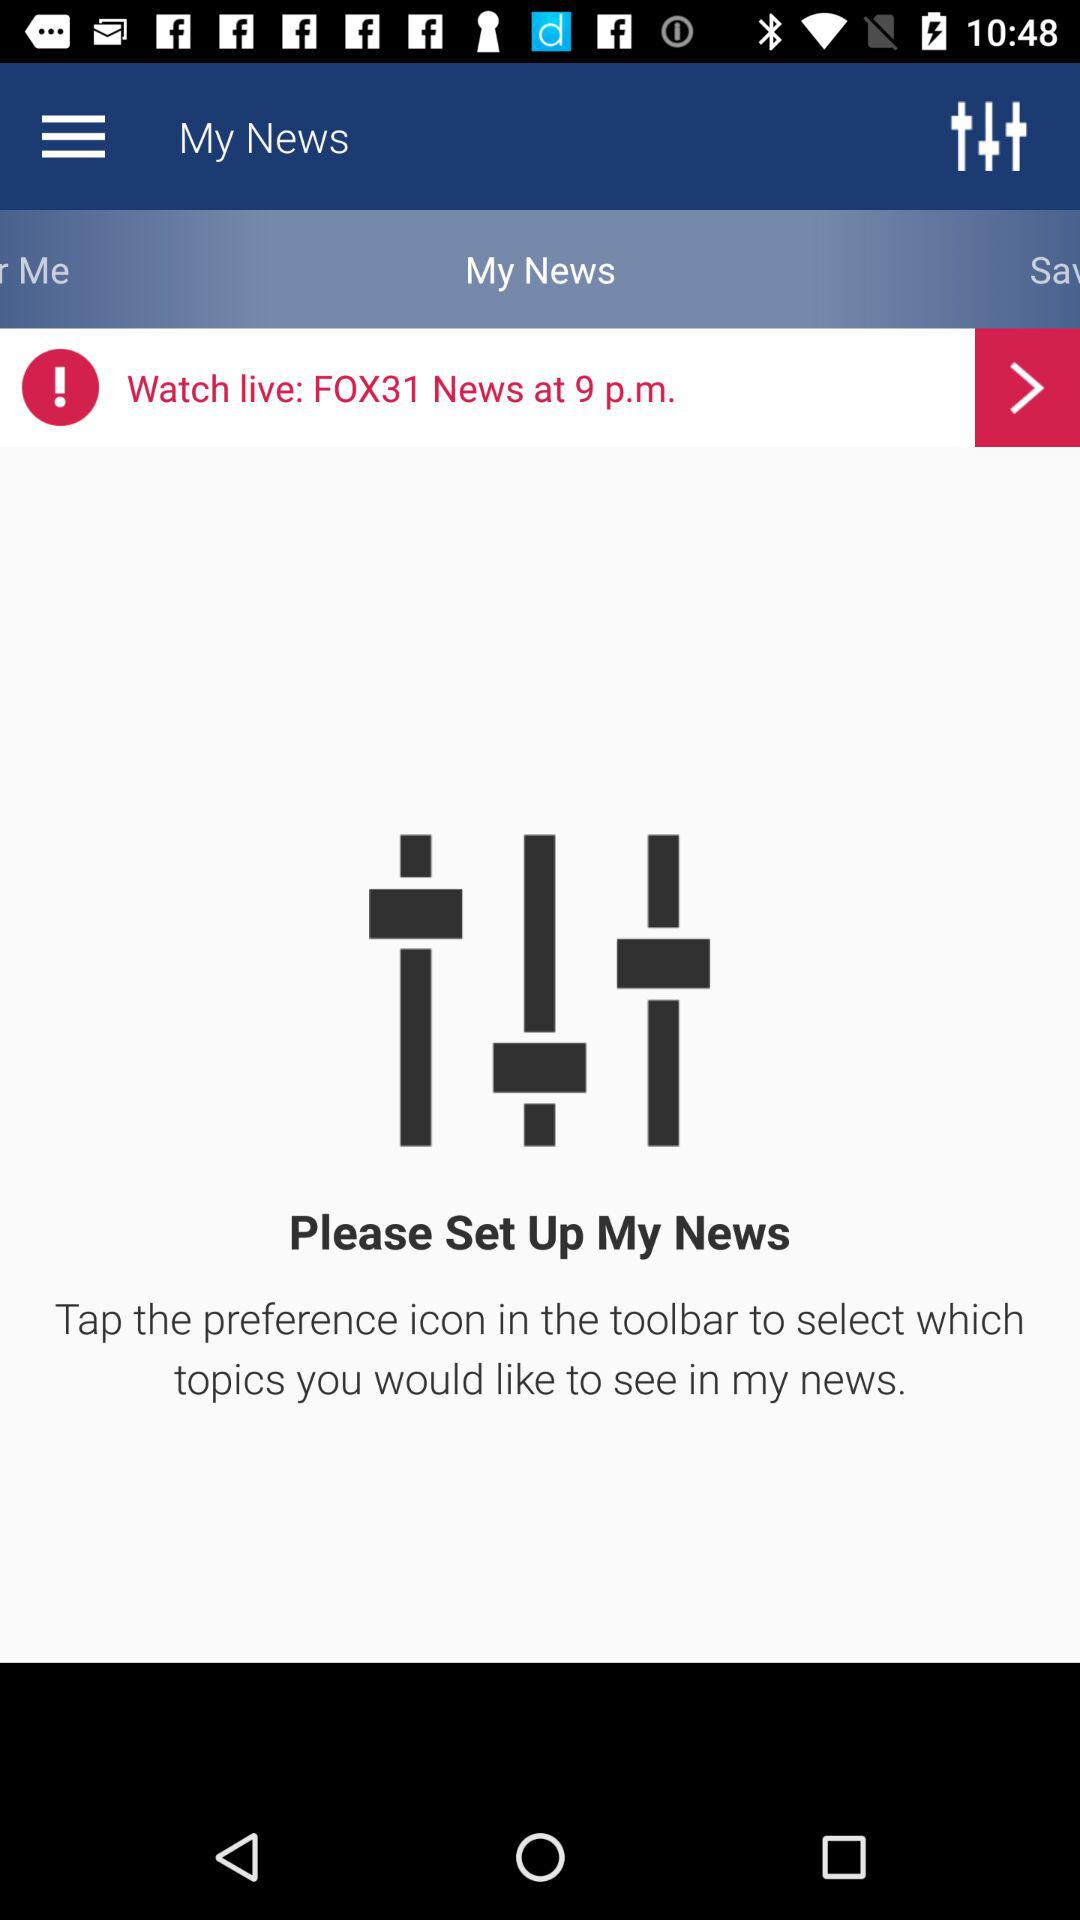When will the news go live? The news will go live at 9 p.m. 